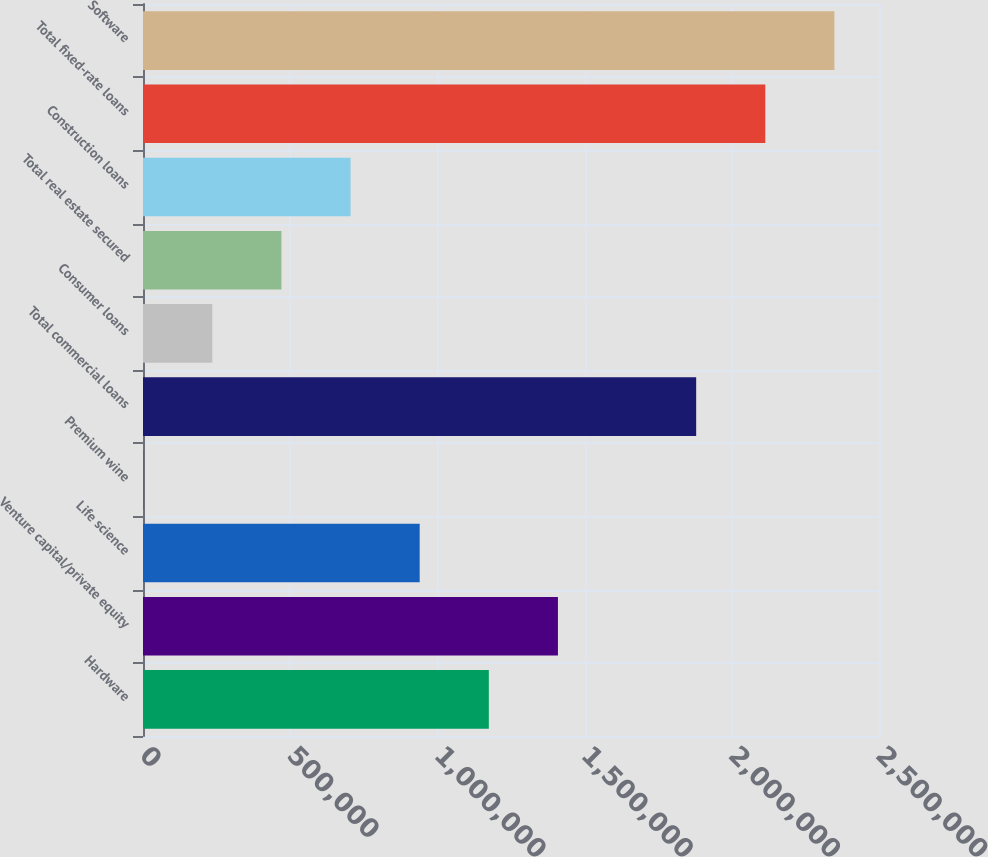Convert chart to OTSL. <chart><loc_0><loc_0><loc_500><loc_500><bar_chart><fcel>Hardware<fcel>Venture capital/private equity<fcel>Life science<fcel>Premium wine<fcel>Total commercial loans<fcel>Consumer loans<fcel>Total real estate secured<fcel>Construction loans<fcel>Total fixed-rate loans<fcel>Software<nl><fcel>1.17463e+06<fcel>1.40942e+06<fcel>939846<fcel>699<fcel>1.87899e+06<fcel>235486<fcel>470273<fcel>705059<fcel>2.11378e+06<fcel>2.34857e+06<nl></chart> 